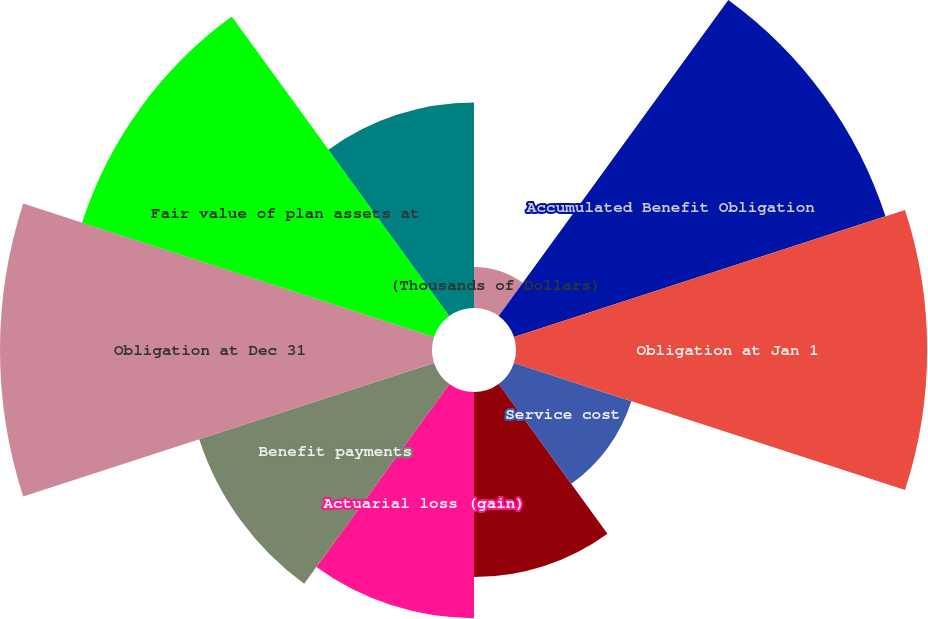Convert chart. <chart><loc_0><loc_0><loc_500><loc_500><pie_chart><fcel>(Thousands of Dollars)<fcel>Accumulated Benefit Obligation<fcel>Obligation at Jan 1<fcel>Service cost<fcel>Interest cost<fcel>Actuarial loss (gain)<fcel>Benefit payments<fcel>Obligation at Dec 31<fcel>Fair value of plan assets at<fcel>Actual return (loss) on plan<nl><fcel>1.56%<fcel>14.84%<fcel>15.62%<fcel>4.69%<fcel>7.03%<fcel>8.59%<fcel>9.38%<fcel>16.41%<fcel>14.06%<fcel>7.81%<nl></chart> 